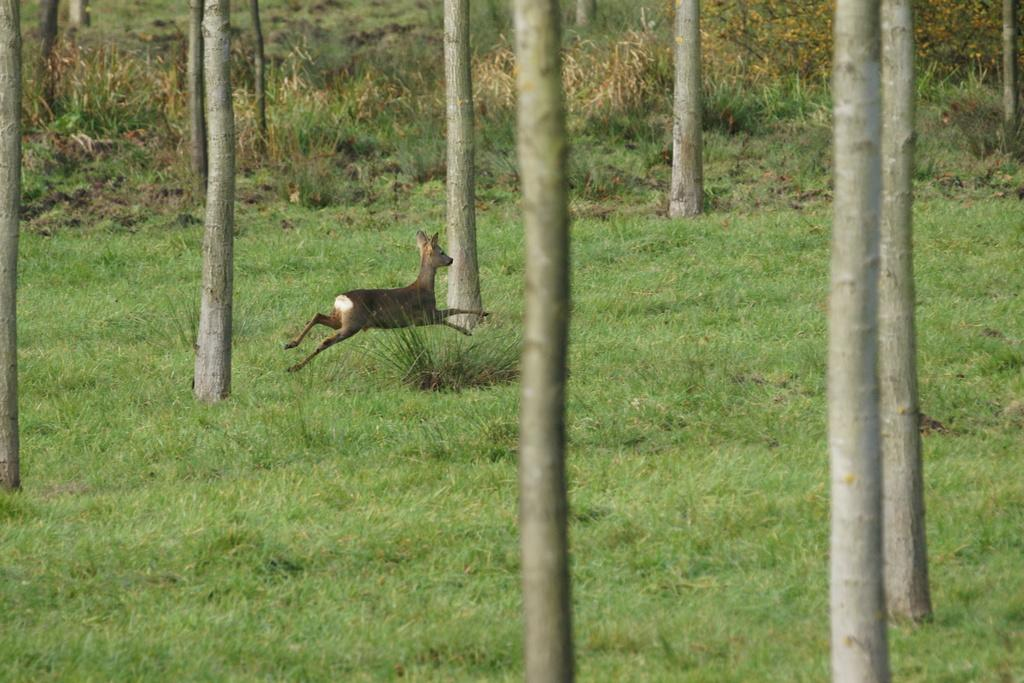What type of animal can be seen in the image? There is an animal in the image, but its specific type cannot be determined from the provided facts. What colors are present on the animal in the image? The animal is brown and cream in color. What action is the animal performing in the image? The animal is jumping in the air. What type of vegetation is visible in the image? There are trees visible in the image. What is the ground made of in the image? There is grass on the floor in the image. How many servants are attending to the animal in the image? There is no mention of servants or any human presence in the image. What type of brick is used to build the wall behind the animal in the image? There is no wall or brick visible in the image. 